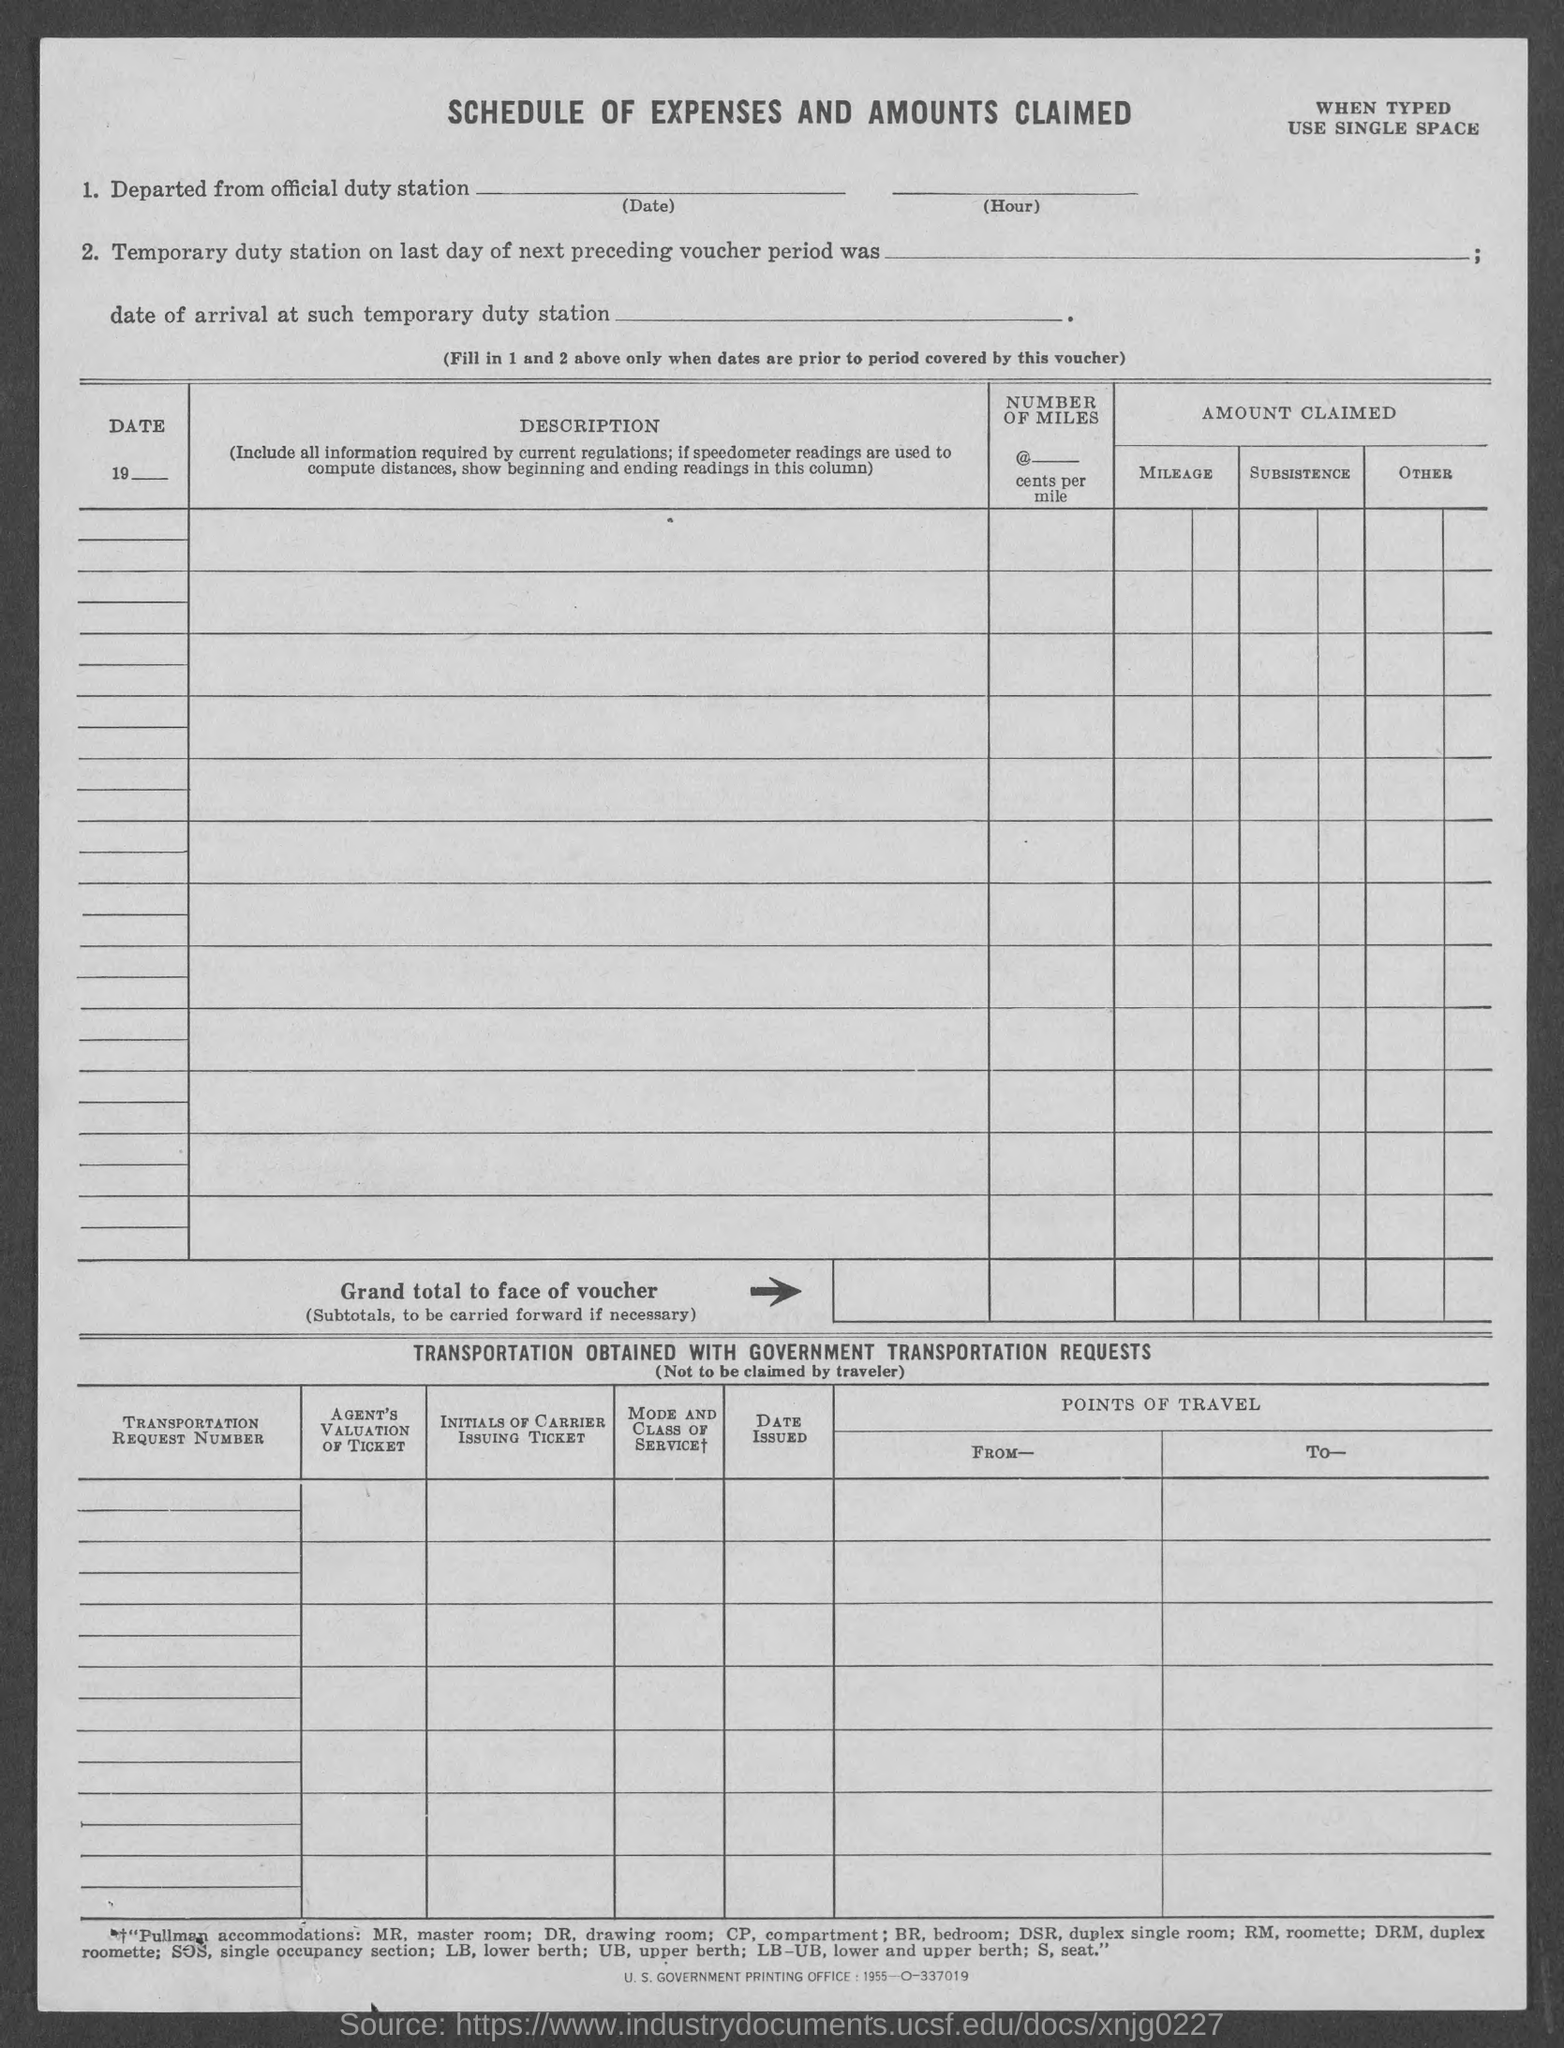What is the title?
Make the answer very short. Schedule of Expenses and Amounts Claimed. What does sos stand for?
Keep it short and to the point. Single occupancy section. What is the heading of the second table?
Provide a succinct answer. Transportation obtained with Government Transportation Requests. 